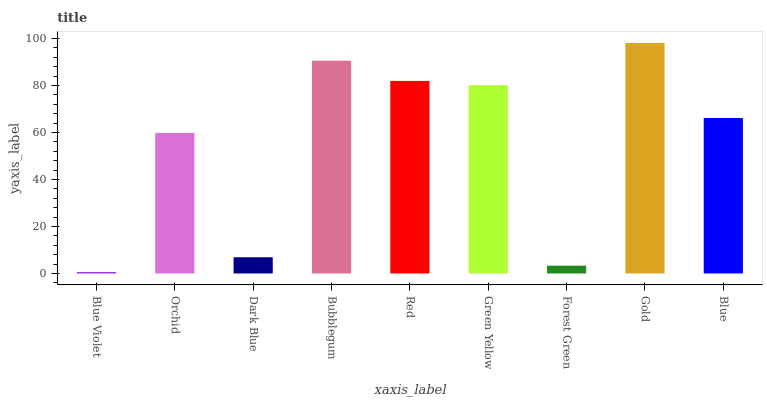Is Blue Violet the minimum?
Answer yes or no. Yes. Is Gold the maximum?
Answer yes or no. Yes. Is Orchid the minimum?
Answer yes or no. No. Is Orchid the maximum?
Answer yes or no. No. Is Orchid greater than Blue Violet?
Answer yes or no. Yes. Is Blue Violet less than Orchid?
Answer yes or no. Yes. Is Blue Violet greater than Orchid?
Answer yes or no. No. Is Orchid less than Blue Violet?
Answer yes or no. No. Is Blue the high median?
Answer yes or no. Yes. Is Blue the low median?
Answer yes or no. Yes. Is Forest Green the high median?
Answer yes or no. No. Is Forest Green the low median?
Answer yes or no. No. 